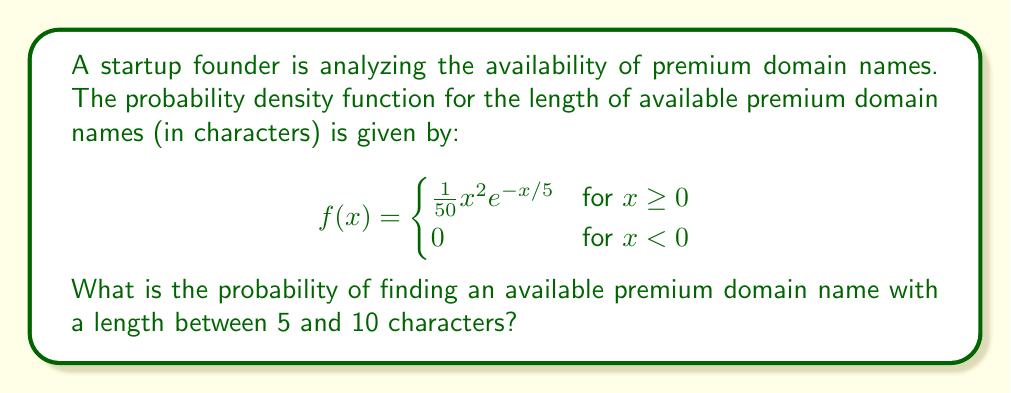Give your solution to this math problem. To find the probability of a domain name length between 5 and 10 characters, we need to integrate the probability density function over this interval:

$$P(5 \leq X \leq 10) = \int_5^{10} f(x) dx = \int_5^{10} \frac{1}{50}x^2e^{-x/5} dx$$

This integral doesn't have a straightforward analytical solution, so we'll use integration by parts twice:

Let $u = x^2$ and $dv = e^{-x/5} dx$

Then $du = 2x dx$ and $v = -5e^{-x/5}$

First integration by parts:

$$\int_5^{10} \frac{1}{50}x^2e^{-x/5} dx = -\frac{1}{10}x^2e^{-x/5}\bigg|_5^{10} + \int_5^{10} \frac{1}{5}xe^{-x/5} dx$$

Now for the second integral, let $u = x$ and $dv = e^{-x/5} dx$

Then $du = dx$ and $v = -5e^{-x/5}$

Second integration by parts:

$$\int_5^{10} \frac{1}{5}xe^{-x/5} dx = -xe^{-x/5}\bigg|_5^{10} + \int_5^{10} e^{-x/5} dx$$

The last integral is straightforward:

$$\int_5^{10} e^{-x/5} dx = -5e^{-x/5}\bigg|_5^{10}$$

Putting it all together:

$$P(5 \leq X \leq 10) = \left(-\frac{1}{10}x^2e^{-x/5} - xe^{-x/5} - 5e^{-x/5}\right)\bigg|_5^{10}$$

Evaluating at the limits:

$$= \left(-\frac{1}{10}(10^2)e^{-10/5} - 10e^{-10/5} - 5e^{-10/5}\right) - \left(-\frac{1}{10}(5^2)e^{-5/5} - 5e^{-5/5} - 5e^{-5/5}\right)$$

$$= (-10e^{-2} - 10e^{-2} - 5e^{-2}) - (-2.5e^{-1} - 5e^{-1} - 5e^{-1})$$

$$= (-25e^{-2}) - (-12.5e^{-1})$$

$$= -25(0.1353) + 12.5(0.3679)$$

$$= -3.3825 + 4.5988$$

$$= 1.2163$$

Therefore, the probability of finding an available premium domain name with a length between 5 and 10 characters is approximately 0.2163 or 21.63%.
Answer: 0.2163 